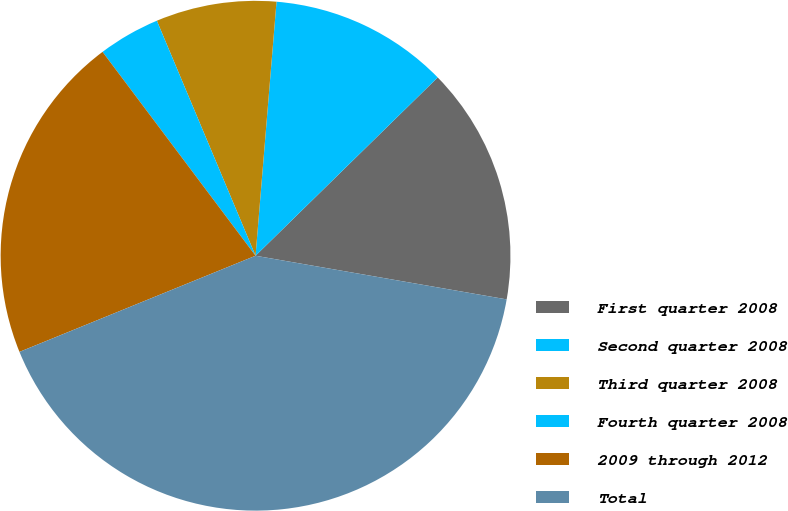Convert chart to OTSL. <chart><loc_0><loc_0><loc_500><loc_500><pie_chart><fcel>First quarter 2008<fcel>Second quarter 2008<fcel>Third quarter 2008<fcel>Fourth quarter 2008<fcel>2009 through 2012<fcel>Total<nl><fcel>15.07%<fcel>11.36%<fcel>7.64%<fcel>3.92%<fcel>20.91%<fcel>41.11%<nl></chart> 